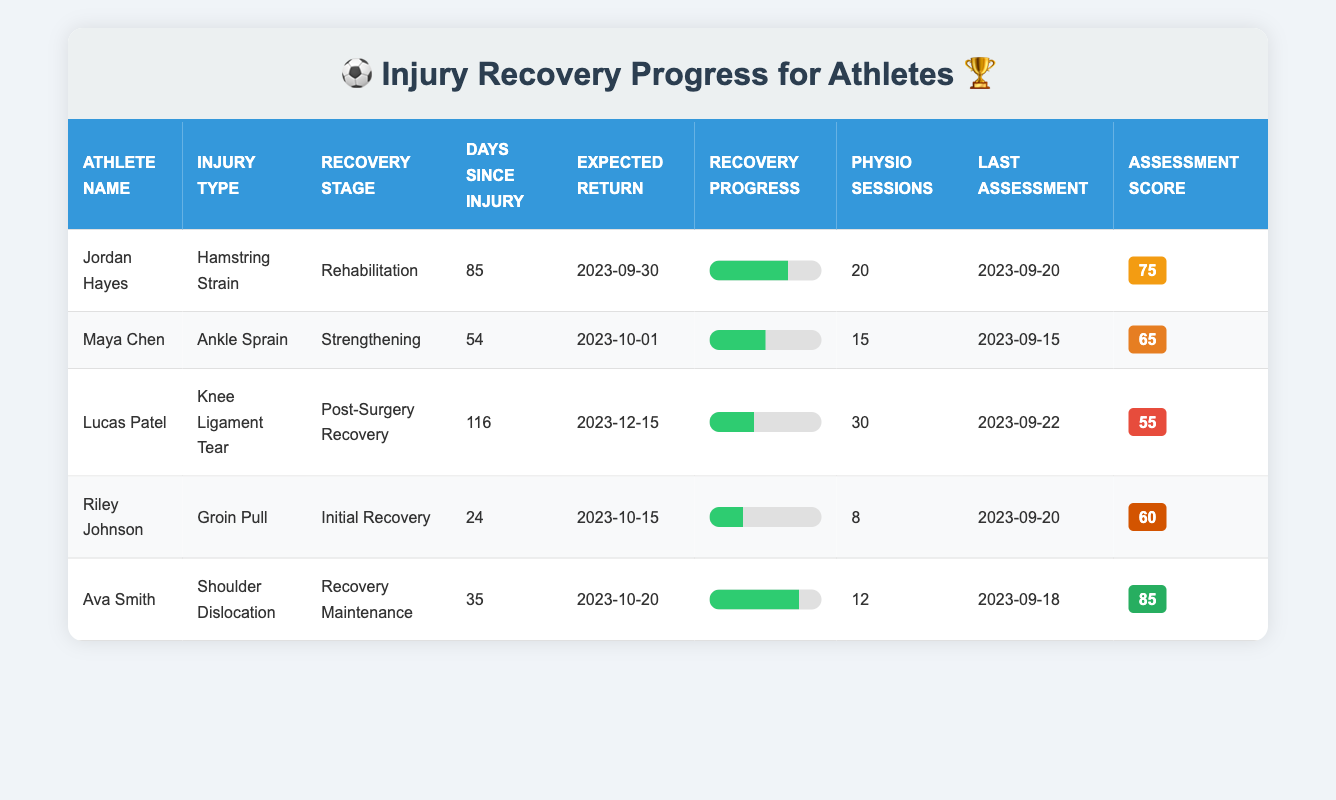What is the injury type for Jordan Hayes? The table lists the athlete's information, where "Jordan Hayes" is mentioned alongside "Injury Type." Referring to the row for Jordan Hayes, the injury type specified is "Hamstring Strain."
Answer: Hamstring Strain How many days has Maya Chen been recovering from her injury? By looking at Maya Chen's row, the "Days Since Injury" column shows the value directly, which is 54 days since the injury occurred on "2023-08-10."
Answer: 54 What is the expected return date for athletes who are currently in "Rehabilitation"? The recovery stage "Rehabilitation" corresponds to "Jordan Hayes." Looking at his row, the expected return date is noted in the "Expected Return" column, which is "2023-09-30."
Answer: 2023-09-30 Which athlete has completed the highest percentage of recovery? The "Recovery Percent Complete" values for each athlete are: Jordan Hayes (70), Maya Chen (50), Lucas Patel (40), Riley Johnson (30), and Ava Smith (80). Comparing them, Ava Smith has the highest recovery percentage at 80.
Answer: Ava Smith Is it true that Riley Johnson has had more physiotherapy sessions than Lucas Patel? The physiotherapy sessions for Riley Johnson are 8 and for Lucas Patel are 30. Therefore, 8 is not greater than 30, making this statement false.
Answer: No What is the average assessment score of all athletes listed? The assessment scores are as follows: Jordan Hayes (75), Maya Chen (65), Lucas Patel (55), Riley Johnson (60), and Ava Smith (85). Summing these gives 75 + 65 + 55 + 60 + 85 = 340. There are 5 athletes, therefore the average is 340 divided by 5, which equals 68.
Answer: 68 Which athlete injured their shoulder, and what was their recovery stage? By checking the "Injury Type" column, "Shoulder Dislocation" is found in the row for Ava Smith. According to her row, the recovery stage is noted as "Recovery Maintenance."
Answer: Ava Smith, Recovery Maintenance How many athletes are in the "Initial Recovery" stage? Looking at the "Recovery Stage" column, only Riley Johnson is listed under "Initial Recovery." Therefore, there is only 1 athlete in that recovery stage.
Answer: 1 